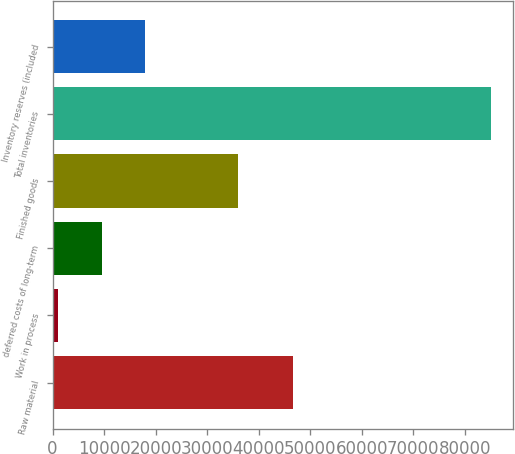Convert chart. <chart><loc_0><loc_0><loc_500><loc_500><bar_chart><fcel>Raw material<fcel>Work in process<fcel>deferred costs of long-term<fcel>Finished goods<fcel>Total inventories<fcel>Inventory reserves (included<nl><fcel>46572<fcel>1103<fcel>9496.5<fcel>35894<fcel>85038<fcel>17890<nl></chart> 